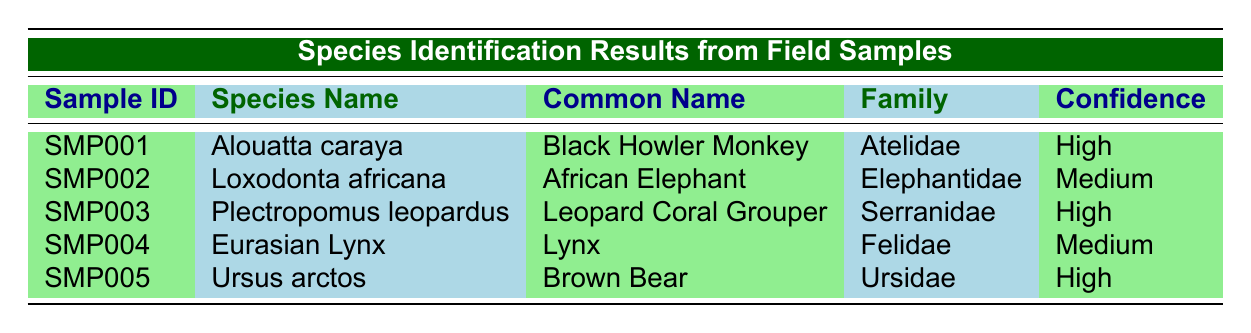What is the common name of the species with sample ID SMP002? The sample ID SMP002 corresponds to the species name Loxodonta africana. The common name listed for this species is African Elephant.
Answer: African Elephant Which species has the highest confidence level in identification? In the table, there are three entries with a high confidence level: Alouatta caraya, Plectropomus leopardus, and Ursus arctos. The first mention is Alouatta caraya.
Answer: Alouatta caraya Is the identification method for sample SMP004 based on genetic analysis? The identification method for sample SMP004 is listed as Footprint Analysis, which is not a genetic analysis method. Therefore, the answer is no.
Answer: No How many species listed are classified under the family "Felidae"? In the table, only one species is part of the family Felidae, which is the Eurasian Lynx.
Answer: 1 What is the habitat type of the species identified as Plectropomus leopardus? The habitat type for Plectropomus leopardus is listed as Marine in the table.
Answer: Marine Which species was collected in a location with a habitat type classified as Forest? There are two species collected in a habitat type classified as Forest: Alouatta caraya and Ursus arctos. The first species listed is Alouatta caraya.
Answer: Alouatta caraya What is the average confidence level of all the species identified? The confidence levels are High, Medium, High, Medium, and High. Converting these into numerical values (High=1, Medium=0.5), we get (1 + 0.5 + 1 + 0.5 + 1) = 4. The average is then 4/5 = 0.8, which corresponds to a confidence level of between High and Medium.
Answer: Approximately High Is there any species identified with a habitat type of Savannah? Yes, the African Elephant, identified with sample ID SMP002, is described as being in a habitat type classified as Savannah.
Answer: Yes 